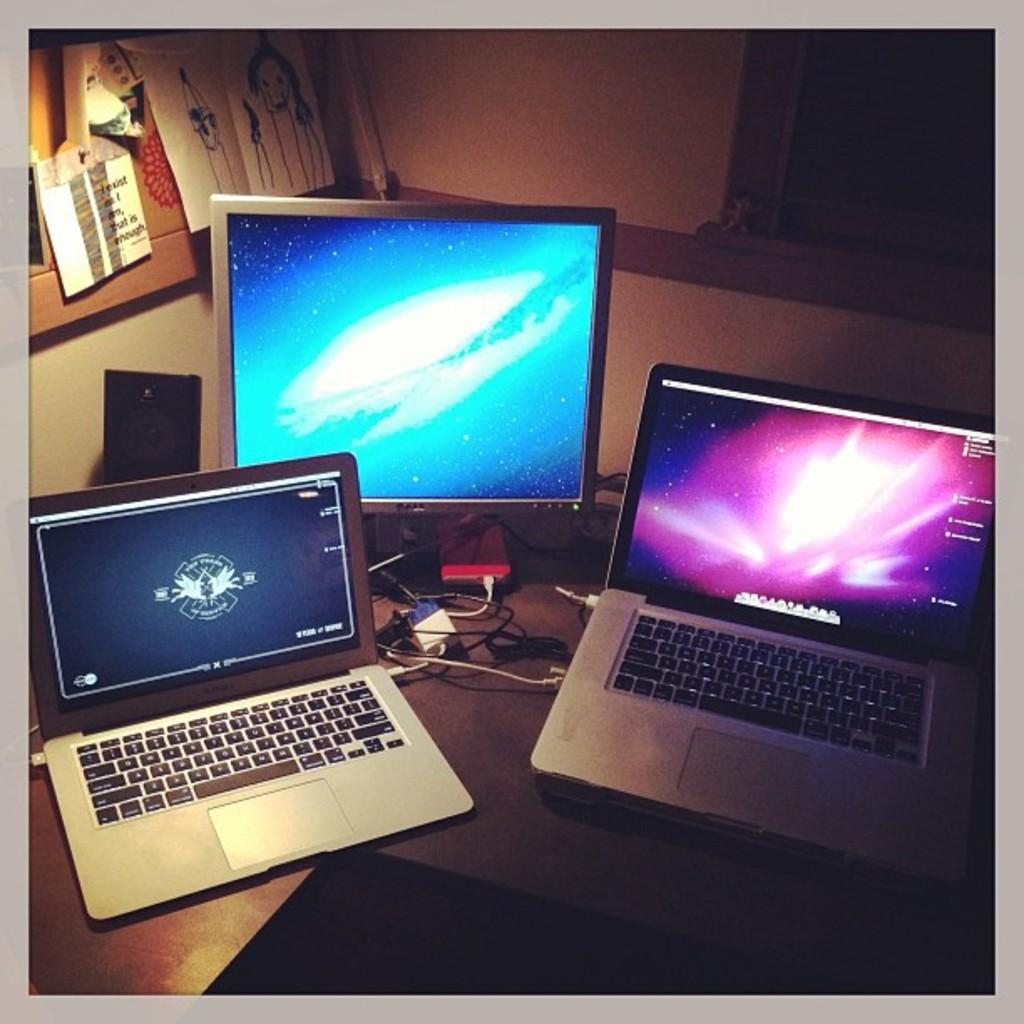How many laptops can be seen in the image? There are two laptops in the image. What other electronic device is present in the image? There is a monitor in the image. What type of background can be seen in the image? There is a wall visible in the image. What is attached to the wall in the image? Papers are pasted on a board that is attached to the wall. What type of breakfast is being prepared on the laptops in the image? There is no breakfast being prepared in the image; the laptops are not related to food preparation. 